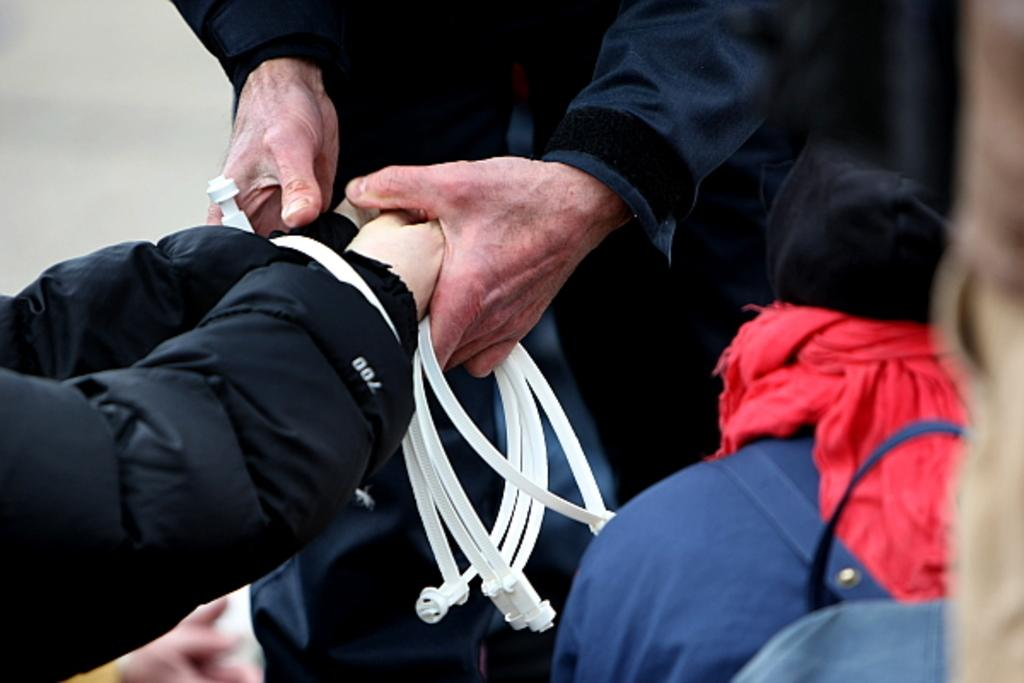What is happening between the two people in the image? There is a person holding another person's hands in the image. What color can be observed in some of the objects in the image? There are objects in the image that are white in color. Can you describe the person on the right side of the image? There is another person on the right side of the image. What type of coal is being used by the person on the left side of the image? There is no coal present in the image. How does the clam on the person's stomach affect their balance in the image? There is no clam or person's stomach mentioned in the image. 